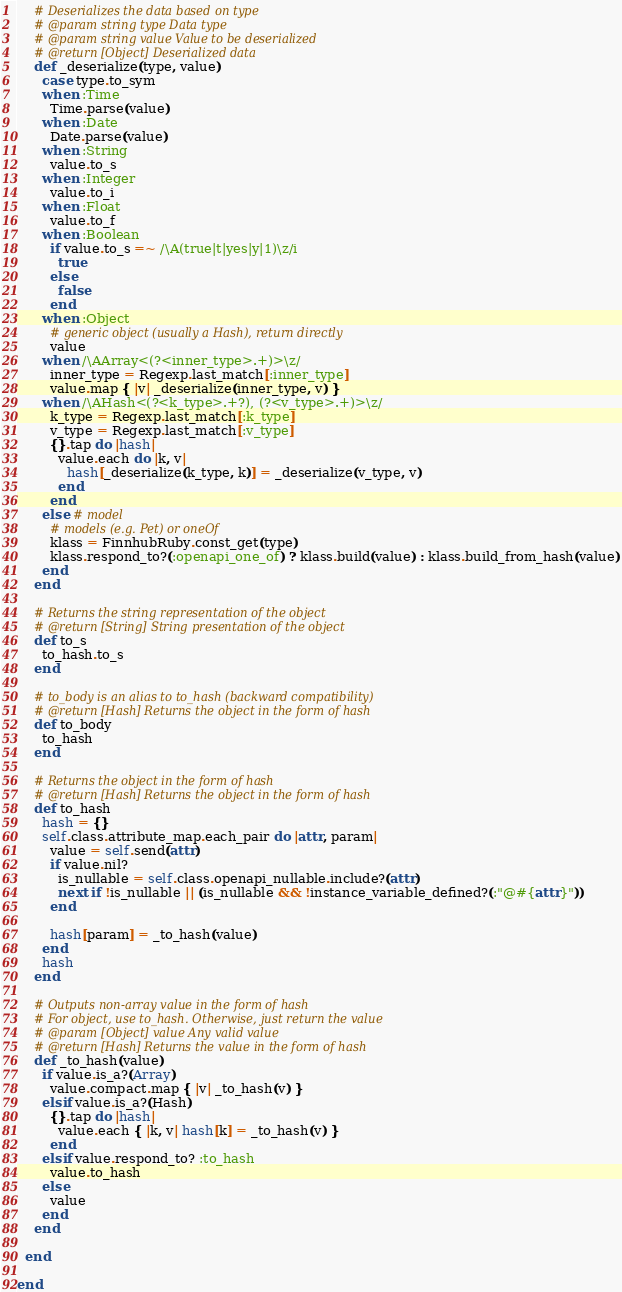Convert code to text. <code><loc_0><loc_0><loc_500><loc_500><_Ruby_>
    # Deserializes the data based on type
    # @param string type Data type
    # @param string value Value to be deserialized
    # @return [Object] Deserialized data
    def _deserialize(type, value)
      case type.to_sym
      when :Time
        Time.parse(value)
      when :Date
        Date.parse(value)
      when :String
        value.to_s
      when :Integer
        value.to_i
      when :Float
        value.to_f
      when :Boolean
        if value.to_s =~ /\A(true|t|yes|y|1)\z/i
          true
        else
          false
        end
      when :Object
        # generic object (usually a Hash), return directly
        value
      when /\AArray<(?<inner_type>.+)>\z/
        inner_type = Regexp.last_match[:inner_type]
        value.map { |v| _deserialize(inner_type, v) }
      when /\AHash<(?<k_type>.+?), (?<v_type>.+)>\z/
        k_type = Regexp.last_match[:k_type]
        v_type = Regexp.last_match[:v_type]
        {}.tap do |hash|
          value.each do |k, v|
            hash[_deserialize(k_type, k)] = _deserialize(v_type, v)
          end
        end
      else # model
        # models (e.g. Pet) or oneOf
        klass = FinnhubRuby.const_get(type)
        klass.respond_to?(:openapi_one_of) ? klass.build(value) : klass.build_from_hash(value)
      end
    end

    # Returns the string representation of the object
    # @return [String] String presentation of the object
    def to_s
      to_hash.to_s
    end

    # to_body is an alias to to_hash (backward compatibility)
    # @return [Hash] Returns the object in the form of hash
    def to_body
      to_hash
    end

    # Returns the object in the form of hash
    # @return [Hash] Returns the object in the form of hash
    def to_hash
      hash = {}
      self.class.attribute_map.each_pair do |attr, param|
        value = self.send(attr)
        if value.nil?
          is_nullable = self.class.openapi_nullable.include?(attr)
          next if !is_nullable || (is_nullable && !instance_variable_defined?(:"@#{attr}"))
        end

        hash[param] = _to_hash(value)
      end
      hash
    end

    # Outputs non-array value in the form of hash
    # For object, use to_hash. Otherwise, just return the value
    # @param [Object] value Any valid value
    # @return [Hash] Returns the value in the form of hash
    def _to_hash(value)
      if value.is_a?(Array)
        value.compact.map { |v| _to_hash(v) }
      elsif value.is_a?(Hash)
        {}.tap do |hash|
          value.each { |k, v| hash[k] = _to_hash(v) }
        end
      elsif value.respond_to? :to_hash
        value.to_hash
      else
        value
      end
    end

  end

end
</code> 